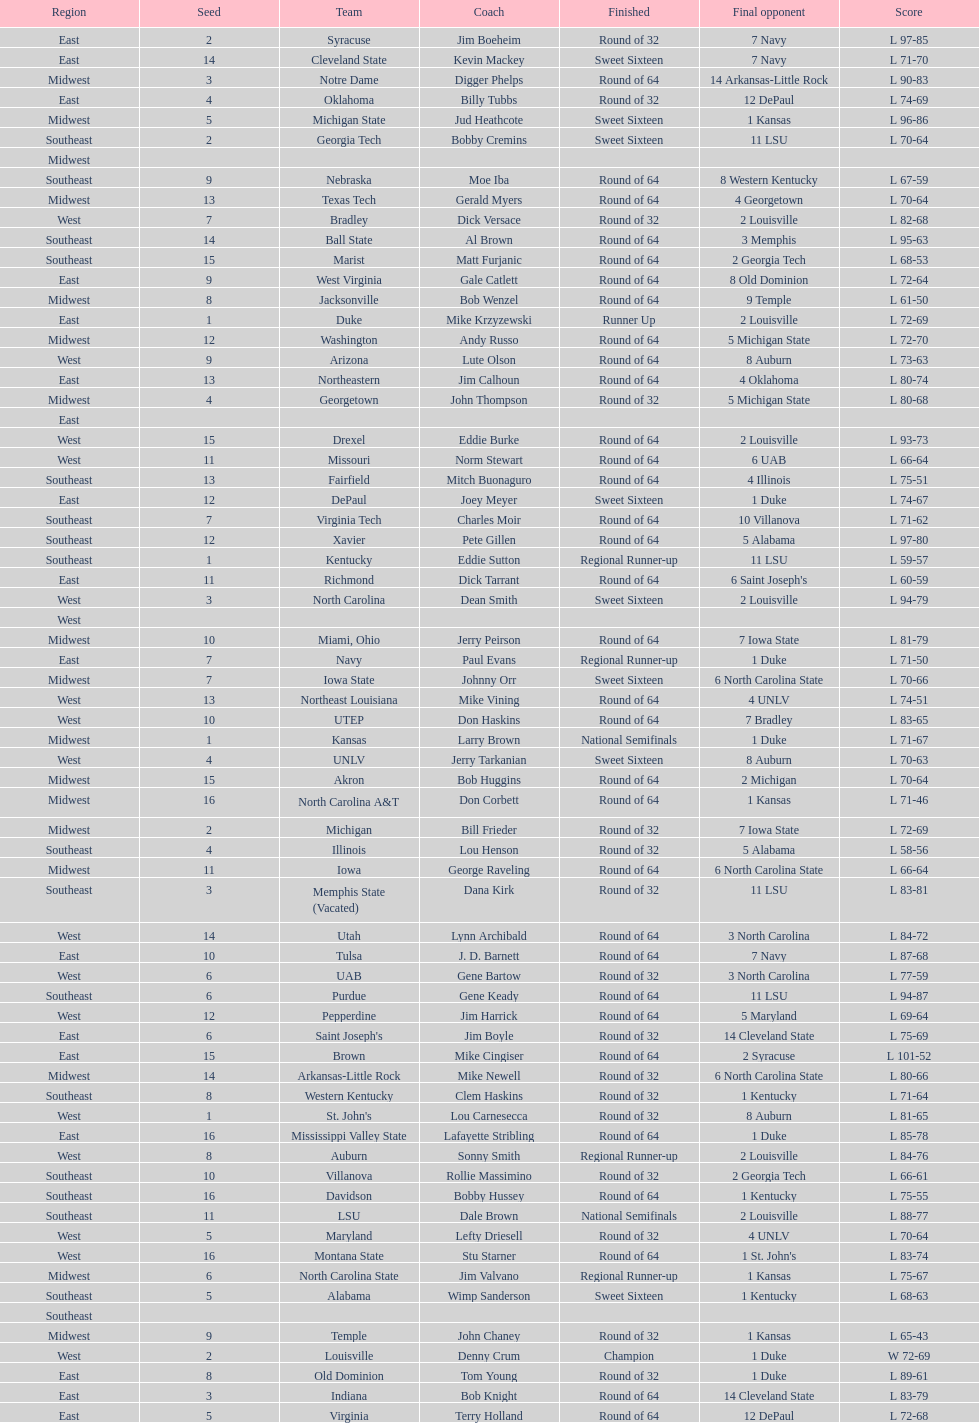What region is listed before the midwest? West. 